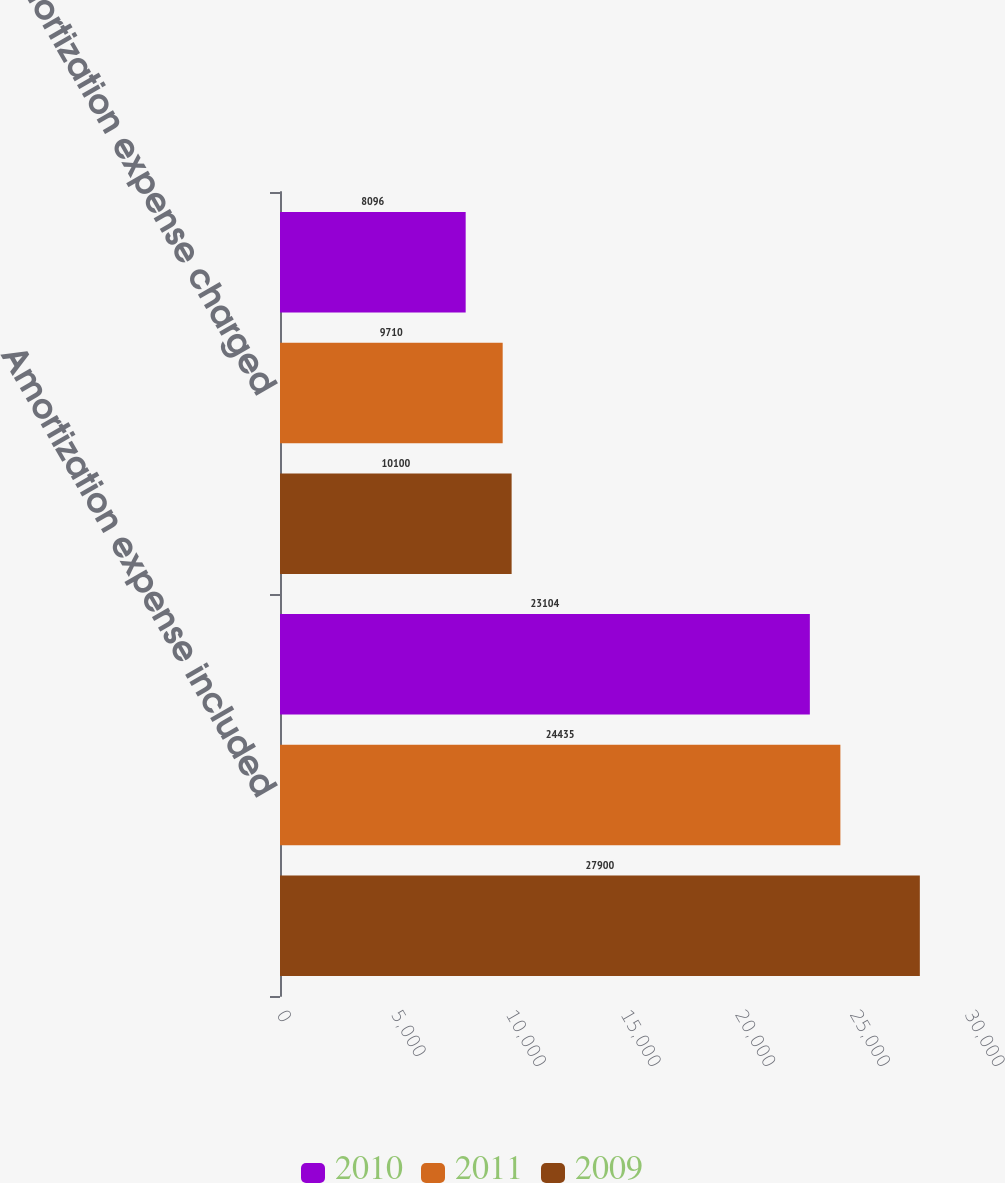Convert chart to OTSL. <chart><loc_0><loc_0><loc_500><loc_500><stacked_bar_chart><ecel><fcel>Amortization expense included<fcel>Amortization expense charged<nl><fcel>2010<fcel>23104<fcel>8096<nl><fcel>2011<fcel>24435<fcel>9710<nl><fcel>2009<fcel>27900<fcel>10100<nl></chart> 